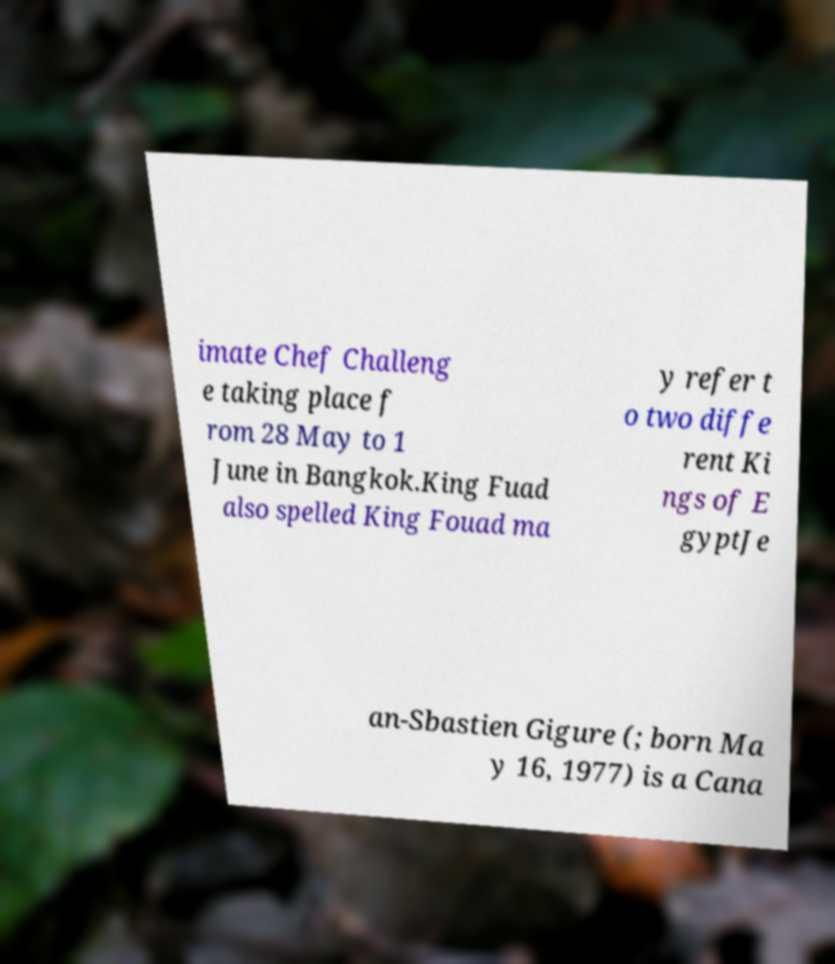Please read and relay the text visible in this image. What does it say? imate Chef Challeng e taking place f rom 28 May to 1 June in Bangkok.King Fuad also spelled King Fouad ma y refer t o two diffe rent Ki ngs of E gyptJe an-Sbastien Gigure (; born Ma y 16, 1977) is a Cana 